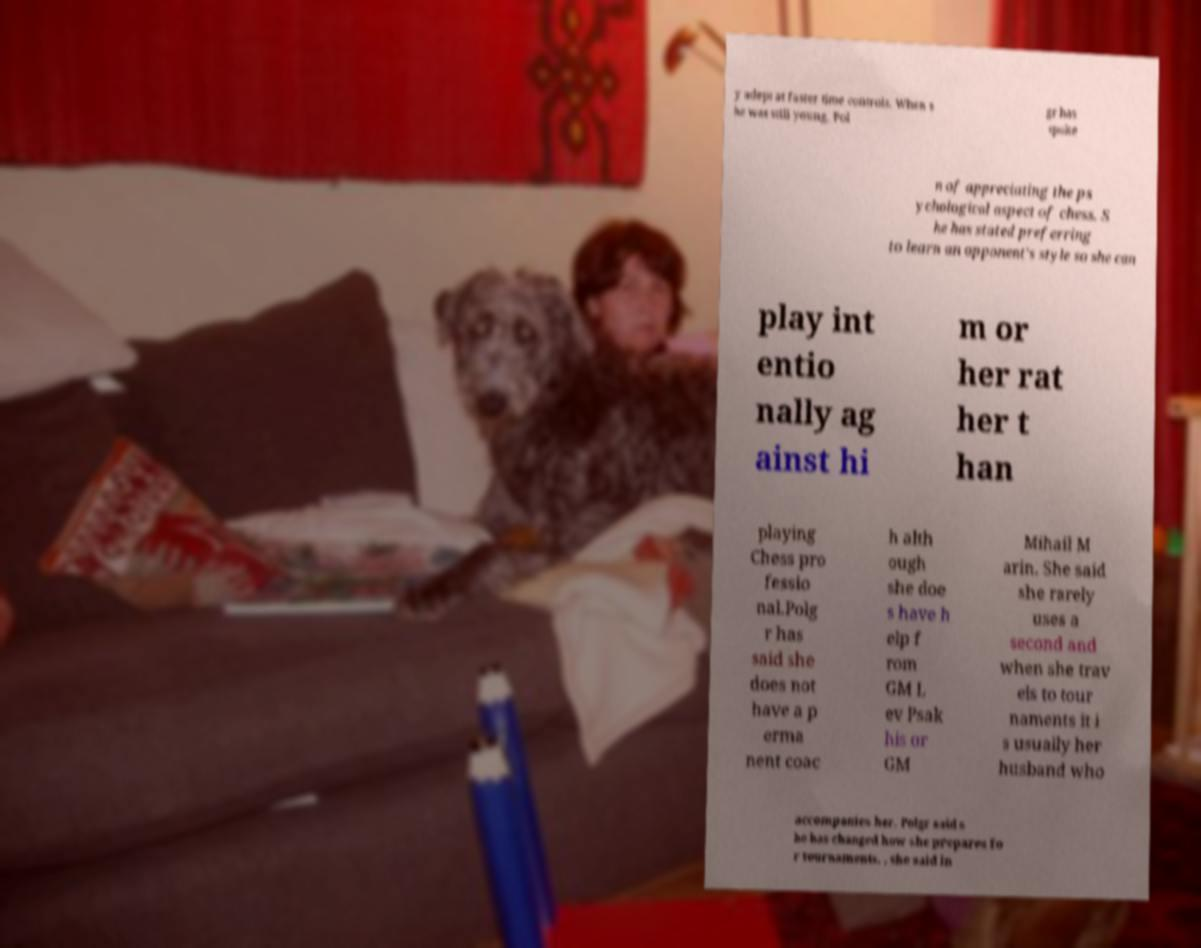What messages or text are displayed in this image? I need them in a readable, typed format. y adept at faster time controls. When s he was still young, Pol gr has spoke n of appreciating the ps ychological aspect of chess. S he has stated preferring to learn an opponent's style so she can play int entio nally ag ainst hi m or her rat her t han playing Chess pro fessio nal.Polg r has said she does not have a p erma nent coac h alth ough she doe s have h elp f rom GM L ev Psak his or GM Mihail M arin. She said she rarely uses a second and when she trav els to tour naments it i s usually her husband who accompanies her. Polgr said s he has changed how she prepares fo r tournaments. , she said in 